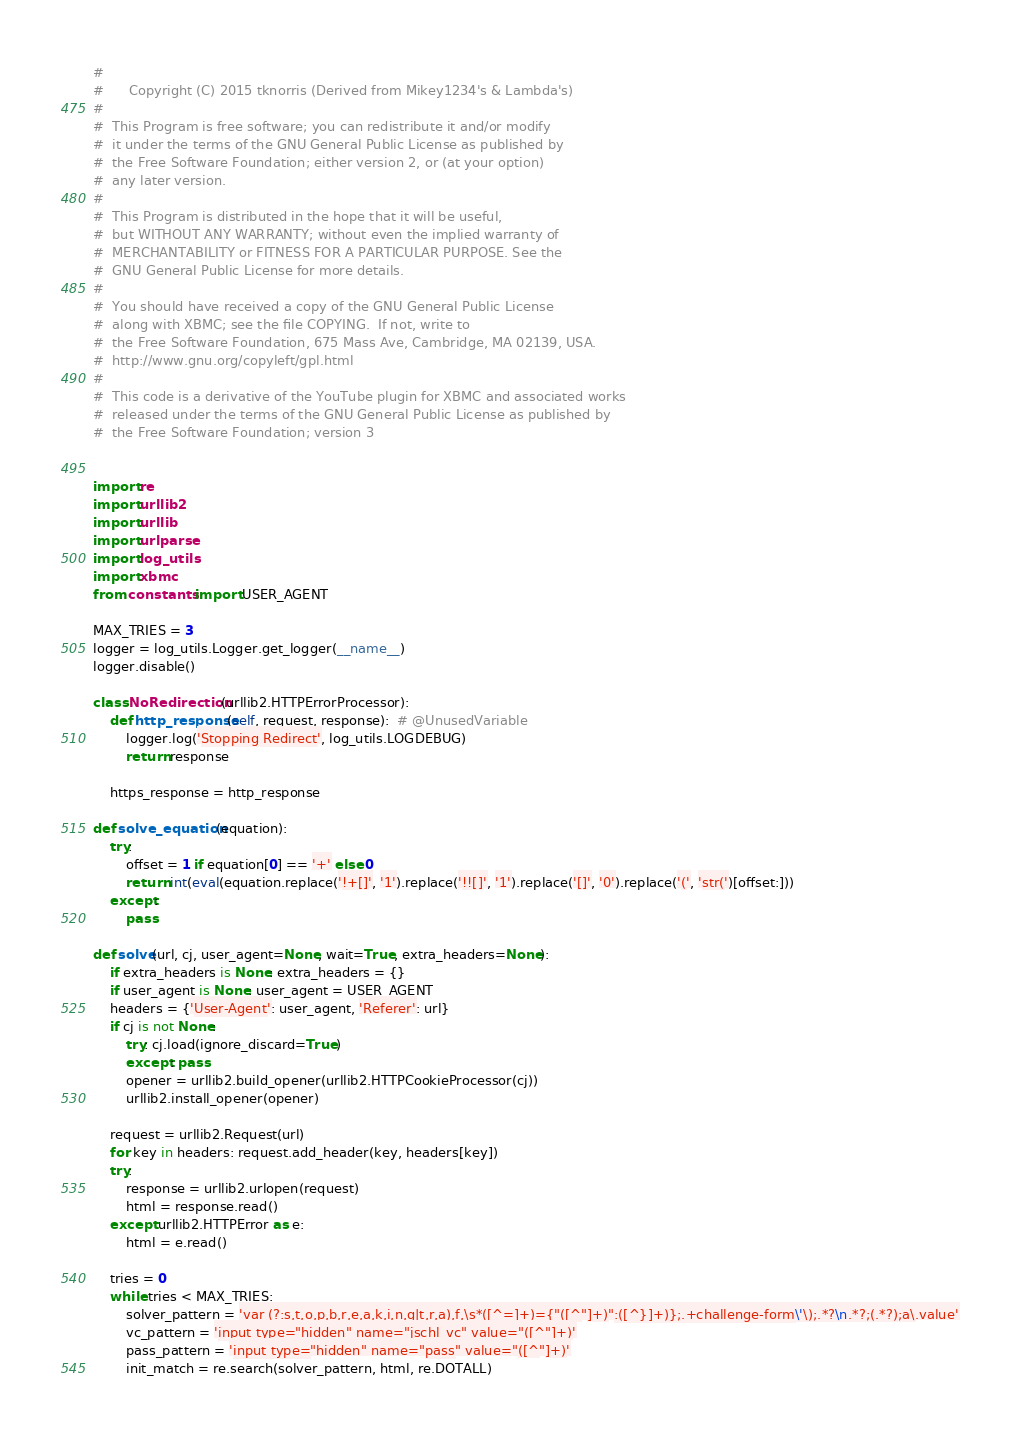<code> <loc_0><loc_0><loc_500><loc_500><_Python_>
#
#      Copyright (C) 2015 tknorris (Derived from Mikey1234's & Lambda's)
#
#  This Program is free software; you can redistribute it and/or modify
#  it under the terms of the GNU General Public License as published by
#  the Free Software Foundation; either version 2, or (at your option)
#  any later version.
#
#  This Program is distributed in the hope that it will be useful,
#  but WITHOUT ANY WARRANTY; without even the implied warranty of
#  MERCHANTABILITY or FITNESS FOR A PARTICULAR PURPOSE. See the
#  GNU General Public License for more details.
#
#  You should have received a copy of the GNU General Public License
#  along with XBMC; see the file COPYING.  If not, write to
#  the Free Software Foundation, 675 Mass Ave, Cambridge, MA 02139, USA.
#  http://www.gnu.org/copyleft/gpl.html
#
#  This code is a derivative of the YouTube plugin for XBMC and associated works
#  released under the terms of the GNU General Public License as published by
#  the Free Software Foundation; version 3


import re
import urllib2
import urllib
import urlparse
import log_utils
import xbmc
from constants import USER_AGENT

MAX_TRIES = 3
logger = log_utils.Logger.get_logger(__name__)
logger.disable()

class NoRedirection(urllib2.HTTPErrorProcessor):
    def http_response(self, request, response):  # @UnusedVariable
        logger.log('Stopping Redirect', log_utils.LOGDEBUG)
        return response

    https_response = http_response

def solve_equation(equation):
    try:
        offset = 1 if equation[0] == '+' else 0
        return int(eval(equation.replace('!+[]', '1').replace('!![]', '1').replace('[]', '0').replace('(', 'str(')[offset:]))
    except:
        pass

def solve(url, cj, user_agent=None, wait=True, extra_headers=None):
    if extra_headers is None: extra_headers = {}
    if user_agent is None: user_agent = USER_AGENT
    headers = {'User-Agent': user_agent, 'Referer': url}
    if cj is not None:
        try: cj.load(ignore_discard=True)
        except: pass
        opener = urllib2.build_opener(urllib2.HTTPCookieProcessor(cj))
        urllib2.install_opener(opener)

    request = urllib2.Request(url)
    for key in headers: request.add_header(key, headers[key])
    try:
        response = urllib2.urlopen(request)
        html = response.read()
    except urllib2.HTTPError as e:
        html = e.read()
    
    tries = 0
    while tries < MAX_TRIES:
        solver_pattern = 'var (?:s,t,o,p,b,r,e,a,k,i,n,g|t,r,a),f,\s*([^=]+)={"([^"]+)":([^}]+)};.+challenge-form\'\);.*?\n.*?;(.*?);a\.value'
        vc_pattern = 'input type="hidden" name="jschl_vc" value="([^"]+)'
        pass_pattern = 'input type="hidden" name="pass" value="([^"]+)'
        init_match = re.search(solver_pattern, html, re.DOTALL)</code> 